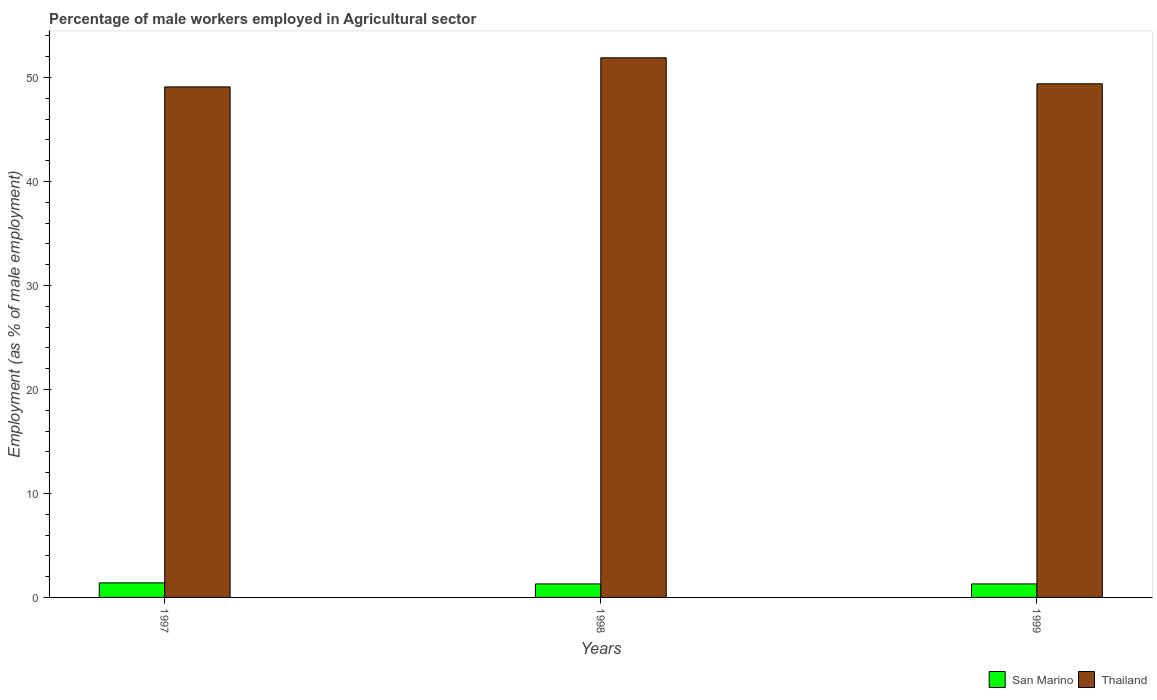How many groups of bars are there?
Provide a succinct answer. 3. Are the number of bars per tick equal to the number of legend labels?
Offer a terse response. Yes. In how many cases, is the number of bars for a given year not equal to the number of legend labels?
Your answer should be compact. 0. What is the percentage of male workers employed in Agricultural sector in San Marino in 1999?
Offer a terse response. 1.3. Across all years, what is the maximum percentage of male workers employed in Agricultural sector in San Marino?
Give a very brief answer. 1.4. Across all years, what is the minimum percentage of male workers employed in Agricultural sector in Thailand?
Offer a terse response. 49.1. In which year was the percentage of male workers employed in Agricultural sector in Thailand minimum?
Offer a very short reply. 1997. What is the total percentage of male workers employed in Agricultural sector in San Marino in the graph?
Give a very brief answer. 4. What is the difference between the percentage of male workers employed in Agricultural sector in Thailand in 1998 and that in 1999?
Offer a very short reply. 2.5. What is the difference between the percentage of male workers employed in Agricultural sector in Thailand in 1997 and the percentage of male workers employed in Agricultural sector in San Marino in 1999?
Your response must be concise. 47.8. What is the average percentage of male workers employed in Agricultural sector in San Marino per year?
Provide a succinct answer. 1.33. In the year 1997, what is the difference between the percentage of male workers employed in Agricultural sector in Thailand and percentage of male workers employed in Agricultural sector in San Marino?
Make the answer very short. 47.7. What is the ratio of the percentage of male workers employed in Agricultural sector in San Marino in 1997 to that in 1999?
Provide a succinct answer. 1.08. Is the percentage of male workers employed in Agricultural sector in Thailand in 1997 less than that in 1999?
Your answer should be very brief. Yes. Is the difference between the percentage of male workers employed in Agricultural sector in Thailand in 1997 and 1999 greater than the difference between the percentage of male workers employed in Agricultural sector in San Marino in 1997 and 1999?
Provide a short and direct response. No. What is the difference between the highest and the second highest percentage of male workers employed in Agricultural sector in Thailand?
Provide a short and direct response. 2.5. What is the difference between the highest and the lowest percentage of male workers employed in Agricultural sector in San Marino?
Provide a succinct answer. 0.1. In how many years, is the percentage of male workers employed in Agricultural sector in Thailand greater than the average percentage of male workers employed in Agricultural sector in Thailand taken over all years?
Provide a short and direct response. 1. Is the sum of the percentage of male workers employed in Agricultural sector in Thailand in 1998 and 1999 greater than the maximum percentage of male workers employed in Agricultural sector in San Marino across all years?
Your response must be concise. Yes. What does the 2nd bar from the left in 1999 represents?
Ensure brevity in your answer.  Thailand. What does the 2nd bar from the right in 1999 represents?
Keep it short and to the point. San Marino. How many years are there in the graph?
Offer a very short reply. 3. What is the difference between two consecutive major ticks on the Y-axis?
Keep it short and to the point. 10. Are the values on the major ticks of Y-axis written in scientific E-notation?
Offer a terse response. No. Where does the legend appear in the graph?
Make the answer very short. Bottom right. What is the title of the graph?
Make the answer very short. Percentage of male workers employed in Agricultural sector. What is the label or title of the X-axis?
Provide a short and direct response. Years. What is the label or title of the Y-axis?
Offer a very short reply. Employment (as % of male employment). What is the Employment (as % of male employment) of San Marino in 1997?
Give a very brief answer. 1.4. What is the Employment (as % of male employment) in Thailand in 1997?
Give a very brief answer. 49.1. What is the Employment (as % of male employment) in San Marino in 1998?
Give a very brief answer. 1.3. What is the Employment (as % of male employment) of Thailand in 1998?
Keep it short and to the point. 51.9. What is the Employment (as % of male employment) in San Marino in 1999?
Offer a terse response. 1.3. What is the Employment (as % of male employment) in Thailand in 1999?
Make the answer very short. 49.4. Across all years, what is the maximum Employment (as % of male employment) of San Marino?
Offer a very short reply. 1.4. Across all years, what is the maximum Employment (as % of male employment) of Thailand?
Ensure brevity in your answer.  51.9. Across all years, what is the minimum Employment (as % of male employment) in San Marino?
Provide a short and direct response. 1.3. Across all years, what is the minimum Employment (as % of male employment) of Thailand?
Ensure brevity in your answer.  49.1. What is the total Employment (as % of male employment) in San Marino in the graph?
Ensure brevity in your answer.  4. What is the total Employment (as % of male employment) of Thailand in the graph?
Keep it short and to the point. 150.4. What is the difference between the Employment (as % of male employment) of San Marino in 1997 and that in 1998?
Make the answer very short. 0.1. What is the difference between the Employment (as % of male employment) of Thailand in 1997 and that in 1998?
Offer a terse response. -2.8. What is the difference between the Employment (as % of male employment) in San Marino in 1997 and that in 1999?
Your answer should be compact. 0.1. What is the difference between the Employment (as % of male employment) in Thailand in 1997 and that in 1999?
Make the answer very short. -0.3. What is the difference between the Employment (as % of male employment) in San Marino in 1997 and the Employment (as % of male employment) in Thailand in 1998?
Give a very brief answer. -50.5. What is the difference between the Employment (as % of male employment) of San Marino in 1997 and the Employment (as % of male employment) of Thailand in 1999?
Offer a terse response. -48. What is the difference between the Employment (as % of male employment) in San Marino in 1998 and the Employment (as % of male employment) in Thailand in 1999?
Provide a succinct answer. -48.1. What is the average Employment (as % of male employment) in Thailand per year?
Offer a very short reply. 50.13. In the year 1997, what is the difference between the Employment (as % of male employment) in San Marino and Employment (as % of male employment) in Thailand?
Offer a very short reply. -47.7. In the year 1998, what is the difference between the Employment (as % of male employment) of San Marino and Employment (as % of male employment) of Thailand?
Provide a short and direct response. -50.6. In the year 1999, what is the difference between the Employment (as % of male employment) in San Marino and Employment (as % of male employment) in Thailand?
Make the answer very short. -48.1. What is the ratio of the Employment (as % of male employment) in Thailand in 1997 to that in 1998?
Provide a short and direct response. 0.95. What is the ratio of the Employment (as % of male employment) of San Marino in 1997 to that in 1999?
Make the answer very short. 1.08. What is the ratio of the Employment (as % of male employment) in Thailand in 1998 to that in 1999?
Keep it short and to the point. 1.05. What is the difference between the highest and the second highest Employment (as % of male employment) of Thailand?
Your response must be concise. 2.5. 